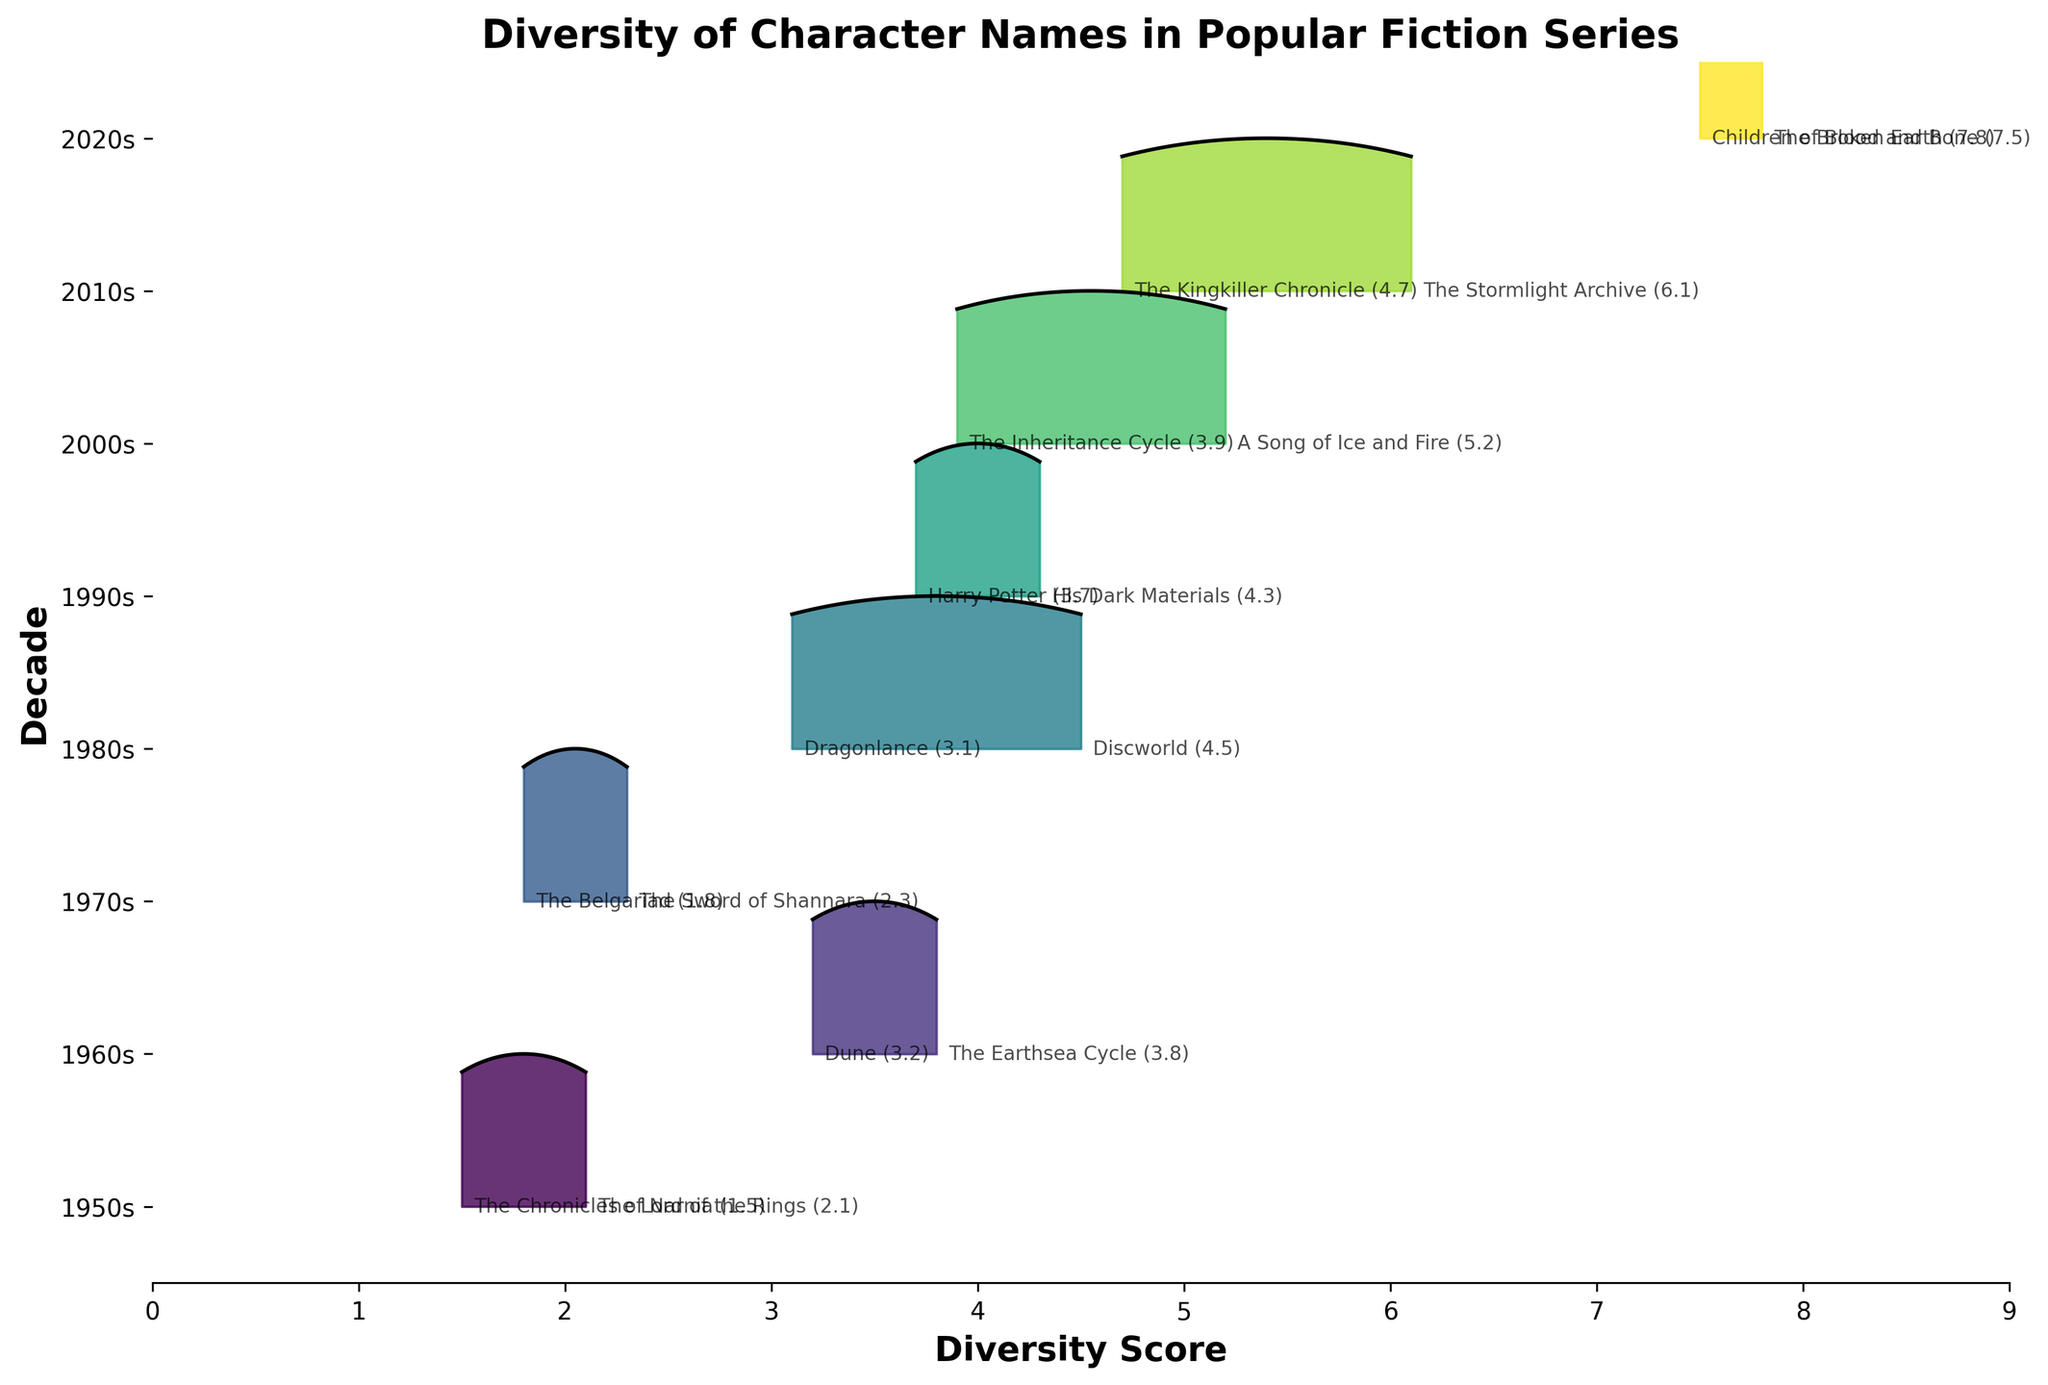What's the title of the plot? The title of the plot is prominently displayed at the top and it reads 'Diversity of Character Names in Popular Fiction Series'.
Answer: Diversity of Character Names in Popular Fiction Series Which decade has the highest diversity score? To determine this, look for the decade that has the highest peak on the x-axis. The highest diversity score seen on the x-axis is around 7.8 in the 2020s.
Answer: 2020s How do the diversity scores in the 1950s compare to the 2020s? By examining the ridgelines for both decades, observe that the 1950s have lower diversity scores (ranging from 1.5 to 2.1) compared to the 2020s, which have higher scores (7.5 to 7.8).
Answer: 1950s have lower scores than 2020s What is the range of diversity scores in the 2000s? Look at the annotated points for the 2000s. The scores range from A Song of Ice and Fire (5.2) to The Inheritance Cycle (3.9). The range is calculated as 5.2 - 3.9.
Answer: 1.3 Which series in the 1980s has the highest diversity score? Identify the series in the 1980s by reading the annotations. Discworld has the highest score with 4.5, which is evident from the peak position.
Answer: Discworld Between 'Harry Potter' and 'His Dark Materials', which one has a higher diversity score? Compare the diversity scores of the two mentioned series. Harry Potter has a score of 3.7 and His Dark Materials has a score of 4.3.
Answer: His Dark Materials What decade shows the most dramatic increase in diversity scores? Compare the progression of peaks across the ridgelines of each decade. The 2020s show a dramatic increase with scores reaching up to 7.8 compared to previous decades.
Answer: 2020s What is the average diversity score for the series in the 1960s? The diversity scores for the 1960s are Dune (3.2) and The Earthsea Cycle (3.8). Calculate the average as (3.2 + 3.8) / 2.
Answer: 3.5 Which decade shows the smallest range of diversity scores? Calculate the range for each decade and identify the smallest. The 1950s have a range from 1.5 to 2.1, which is 0.6.
Answer: 1950s How does 'The Belgariad' (1.8) compare to 'Children of Blood and Bone' (7.5) in terms of diversity score? Compare the scores directly; 'The Belgariad' has a significantly lower diversity score (1.8) than 'Children of Blood and Bone' (7.5).
Answer: 'Children of Blood and Bone' has a higher score 